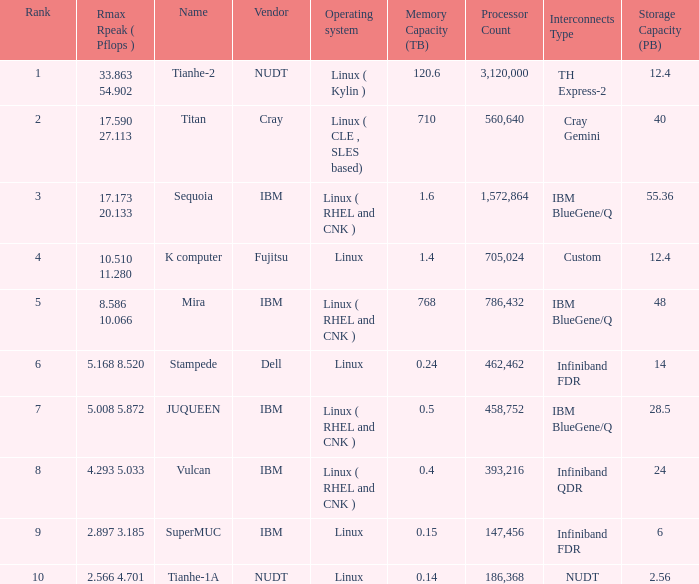What is the name of Rank 5? Mira. 